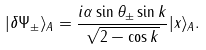<formula> <loc_0><loc_0><loc_500><loc_500>| \delta \Psi _ { \pm } \rangle _ { A } = \frac { i \alpha \sin \theta _ { \pm } \sin k } { \sqrt { 2 - \cos k } } | x \rangle _ { A } .</formula> 